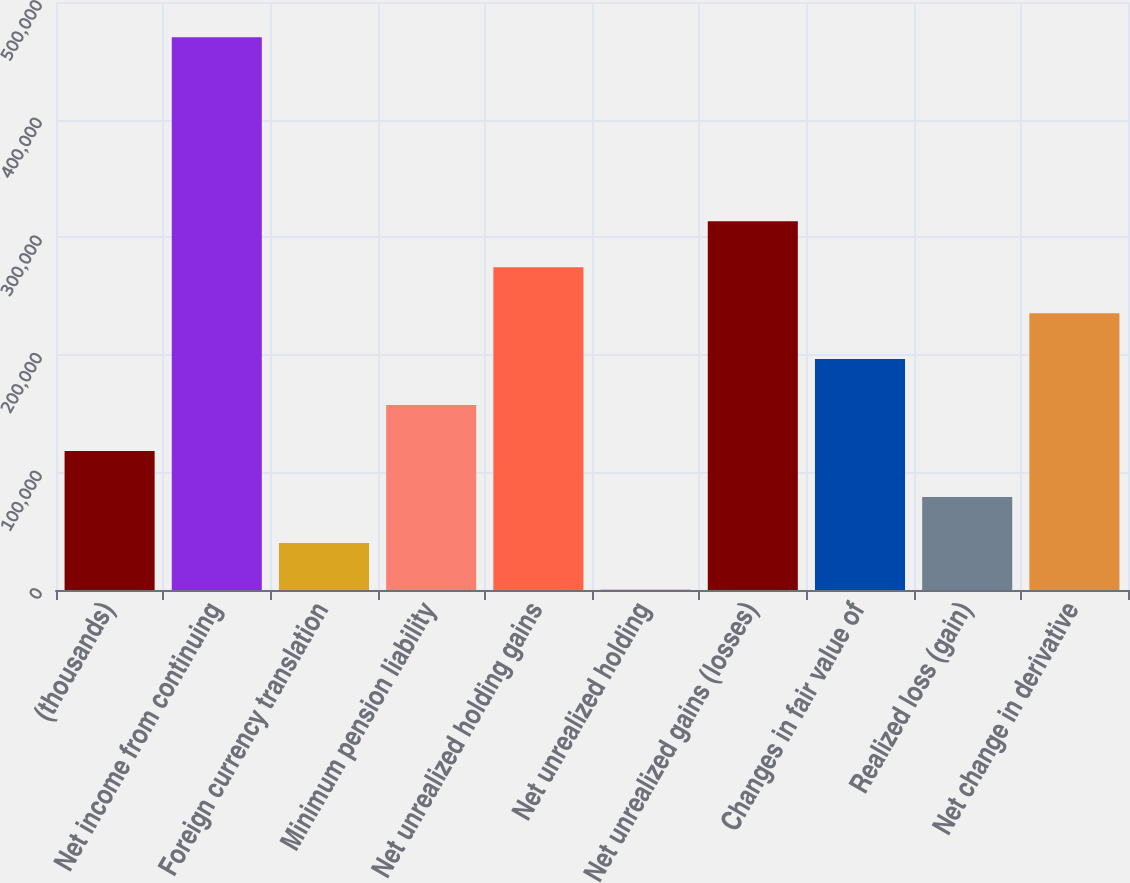Convert chart to OTSL. <chart><loc_0><loc_0><loc_500><loc_500><bar_chart><fcel>(thousands)<fcel>Net income from continuing<fcel>Foreign currency translation<fcel>Minimum pension liability<fcel>Net unrealized holding gains<fcel>Net unrealized holding<fcel>Net unrealized gains (losses)<fcel>Changes in fair value of<fcel>Realized loss (gain)<fcel>Net change in derivative<nl><fcel>118183<fcel>469943<fcel>40014.4<fcel>157268<fcel>274521<fcel>930<fcel>313605<fcel>196352<fcel>79098.8<fcel>235436<nl></chart> 